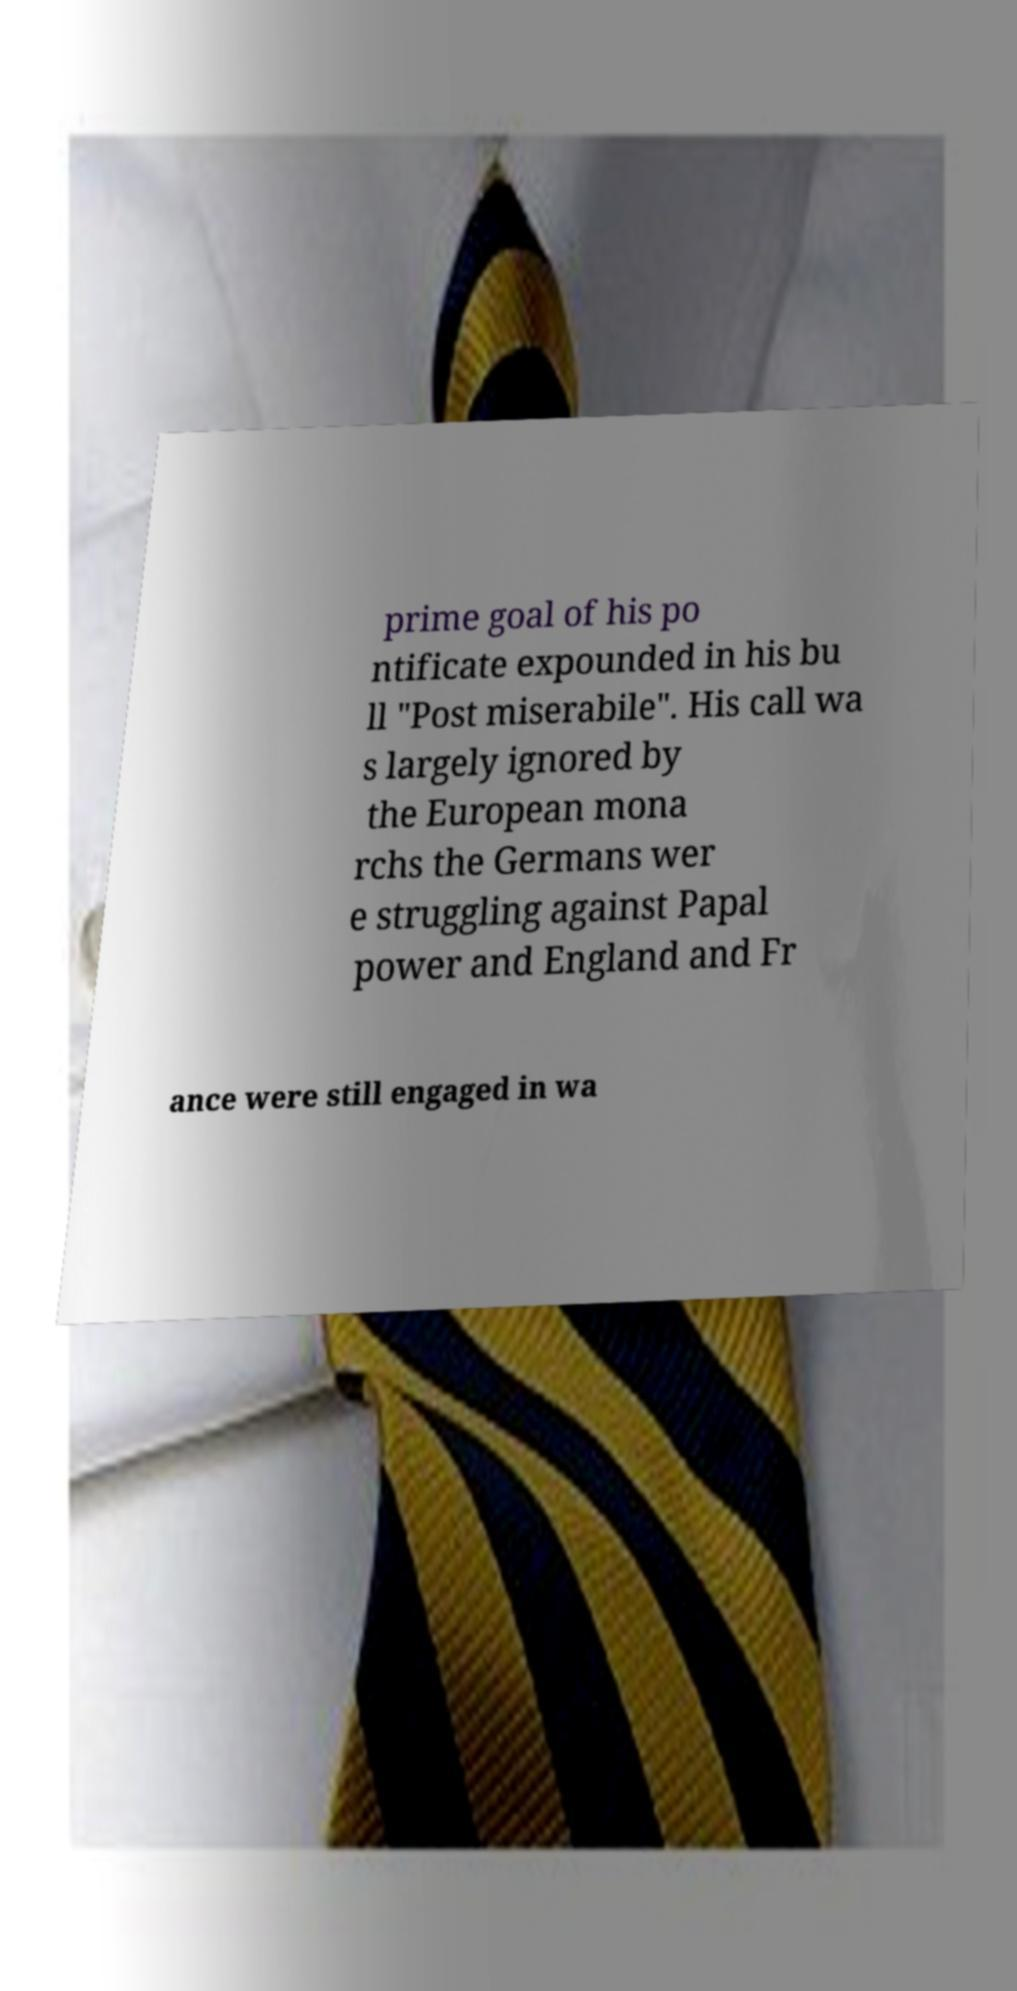Can you read and provide the text displayed in the image?This photo seems to have some interesting text. Can you extract and type it out for me? prime goal of his po ntificate expounded in his bu ll "Post miserabile". His call wa s largely ignored by the European mona rchs the Germans wer e struggling against Papal power and England and Fr ance were still engaged in wa 